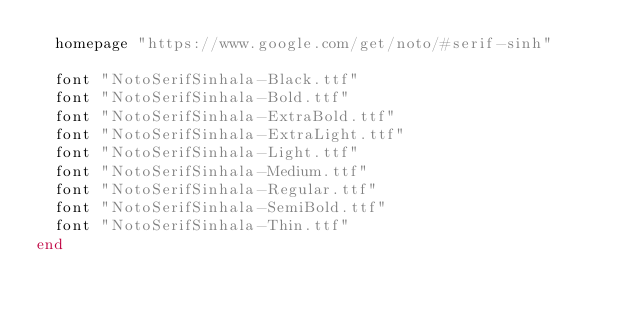Convert code to text. <code><loc_0><loc_0><loc_500><loc_500><_Ruby_>  homepage "https://www.google.com/get/noto/#serif-sinh"

  font "NotoSerifSinhala-Black.ttf"
  font "NotoSerifSinhala-Bold.ttf"
  font "NotoSerifSinhala-ExtraBold.ttf"
  font "NotoSerifSinhala-ExtraLight.ttf"
  font "NotoSerifSinhala-Light.ttf"
  font "NotoSerifSinhala-Medium.ttf"
  font "NotoSerifSinhala-Regular.ttf"
  font "NotoSerifSinhala-SemiBold.ttf"
  font "NotoSerifSinhala-Thin.ttf"
end
</code> 